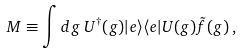<formula> <loc_0><loc_0><loc_500><loc_500>M \equiv \int d g \, U ^ { \dag } ( g ) | e \rangle \langle e | U ( g ) \tilde { f } ( g ) \, ,</formula> 